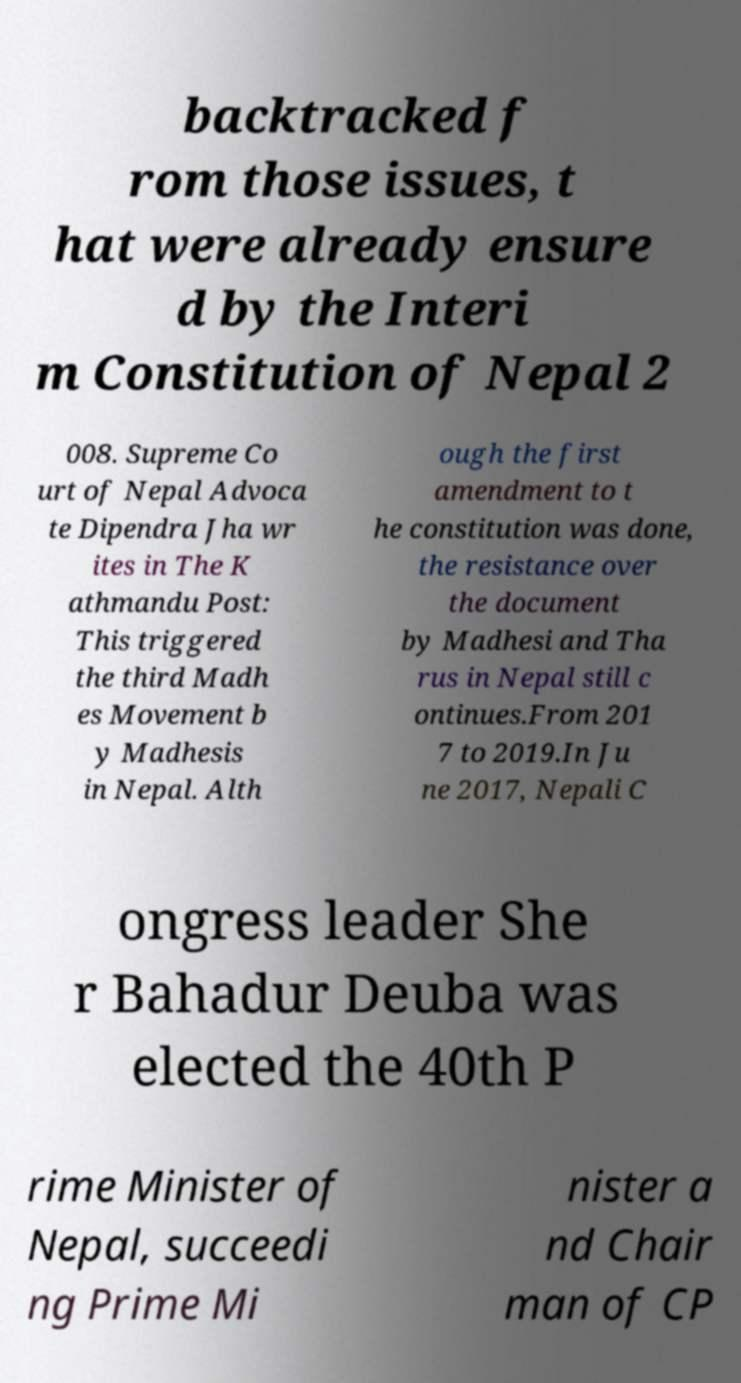Could you assist in decoding the text presented in this image and type it out clearly? backtracked f rom those issues, t hat were already ensure d by the Interi m Constitution of Nepal 2 008. Supreme Co urt of Nepal Advoca te Dipendra Jha wr ites in The K athmandu Post: This triggered the third Madh es Movement b y Madhesis in Nepal. Alth ough the first amendment to t he constitution was done, the resistance over the document by Madhesi and Tha rus in Nepal still c ontinues.From 201 7 to 2019.In Ju ne 2017, Nepali C ongress leader She r Bahadur Deuba was elected the 40th P rime Minister of Nepal, succeedi ng Prime Mi nister a nd Chair man of CP 